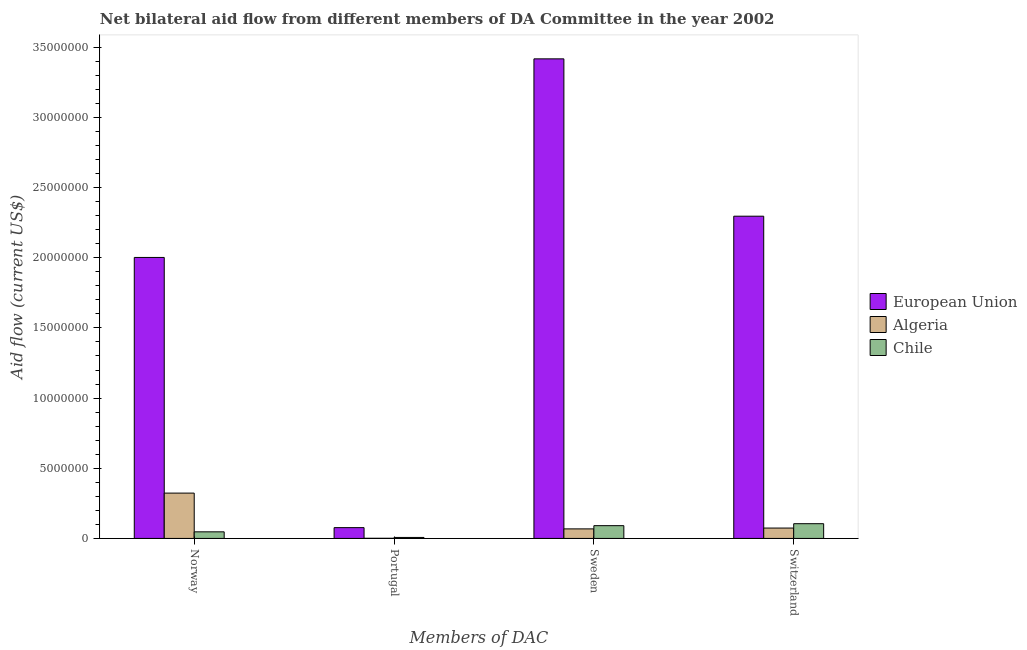How many bars are there on the 2nd tick from the left?
Provide a succinct answer. 3. How many bars are there on the 1st tick from the right?
Ensure brevity in your answer.  3. What is the amount of aid given by switzerland in Algeria?
Provide a succinct answer. 7.40e+05. Across all countries, what is the maximum amount of aid given by norway?
Keep it short and to the point. 2.00e+07. Across all countries, what is the minimum amount of aid given by sweden?
Your response must be concise. 6.80e+05. In which country was the amount of aid given by norway minimum?
Make the answer very short. Chile. What is the total amount of aid given by portugal in the graph?
Your answer should be very brief. 8.50e+05. What is the difference between the amount of aid given by switzerland in Chile and that in European Union?
Keep it short and to the point. -2.19e+07. What is the difference between the amount of aid given by portugal in European Union and the amount of aid given by norway in Algeria?
Ensure brevity in your answer.  -2.46e+06. What is the average amount of aid given by sweden per country?
Offer a terse response. 1.19e+07. What is the difference between the amount of aid given by switzerland and amount of aid given by sweden in Chile?
Make the answer very short. 1.40e+05. In how many countries, is the amount of aid given by norway greater than 29000000 US$?
Offer a terse response. 0. What is the ratio of the amount of aid given by sweden in European Union to that in Chile?
Provide a short and direct response. 37.55. Is the amount of aid given by sweden in European Union less than that in Chile?
Provide a succinct answer. No. Is the difference between the amount of aid given by sweden in European Union and Chile greater than the difference between the amount of aid given by portugal in European Union and Chile?
Ensure brevity in your answer.  Yes. What is the difference between the highest and the second highest amount of aid given by sweden?
Your answer should be very brief. 3.33e+07. What is the difference between the highest and the lowest amount of aid given by norway?
Make the answer very short. 1.96e+07. In how many countries, is the amount of aid given by portugal greater than the average amount of aid given by portugal taken over all countries?
Your answer should be very brief. 1. Is it the case that in every country, the sum of the amount of aid given by sweden and amount of aid given by switzerland is greater than the sum of amount of aid given by portugal and amount of aid given by norway?
Make the answer very short. Yes. What does the 1st bar from the right in Sweden represents?
Provide a succinct answer. Chile. What is the difference between two consecutive major ticks on the Y-axis?
Your response must be concise. 5.00e+06. Are the values on the major ticks of Y-axis written in scientific E-notation?
Your answer should be very brief. No. Does the graph contain any zero values?
Keep it short and to the point. No. Where does the legend appear in the graph?
Offer a terse response. Center right. How many legend labels are there?
Offer a terse response. 3. How are the legend labels stacked?
Your answer should be very brief. Vertical. What is the title of the graph?
Your answer should be very brief. Net bilateral aid flow from different members of DA Committee in the year 2002. Does "Australia" appear as one of the legend labels in the graph?
Keep it short and to the point. No. What is the label or title of the X-axis?
Keep it short and to the point. Members of DAC. What is the Aid flow (current US$) of European Union in Norway?
Provide a short and direct response. 2.00e+07. What is the Aid flow (current US$) of Algeria in Norway?
Offer a very short reply. 3.23e+06. What is the Aid flow (current US$) in European Union in Portugal?
Offer a terse response. 7.70e+05. What is the Aid flow (current US$) of Algeria in Portugal?
Provide a succinct answer. 10000. What is the Aid flow (current US$) in Chile in Portugal?
Ensure brevity in your answer.  7.00e+04. What is the Aid flow (current US$) of European Union in Sweden?
Your answer should be very brief. 3.42e+07. What is the Aid flow (current US$) of Algeria in Sweden?
Provide a short and direct response. 6.80e+05. What is the Aid flow (current US$) of Chile in Sweden?
Your answer should be very brief. 9.10e+05. What is the Aid flow (current US$) of European Union in Switzerland?
Your answer should be compact. 2.30e+07. What is the Aid flow (current US$) of Algeria in Switzerland?
Keep it short and to the point. 7.40e+05. What is the Aid flow (current US$) of Chile in Switzerland?
Keep it short and to the point. 1.05e+06. Across all Members of DAC, what is the maximum Aid flow (current US$) in European Union?
Give a very brief answer. 3.42e+07. Across all Members of DAC, what is the maximum Aid flow (current US$) in Algeria?
Ensure brevity in your answer.  3.23e+06. Across all Members of DAC, what is the maximum Aid flow (current US$) in Chile?
Your answer should be compact. 1.05e+06. Across all Members of DAC, what is the minimum Aid flow (current US$) of European Union?
Ensure brevity in your answer.  7.70e+05. Across all Members of DAC, what is the minimum Aid flow (current US$) in Algeria?
Provide a short and direct response. 10000. What is the total Aid flow (current US$) of European Union in the graph?
Offer a very short reply. 7.79e+07. What is the total Aid flow (current US$) of Algeria in the graph?
Offer a terse response. 4.66e+06. What is the total Aid flow (current US$) of Chile in the graph?
Keep it short and to the point. 2.50e+06. What is the difference between the Aid flow (current US$) of European Union in Norway and that in Portugal?
Your response must be concise. 1.92e+07. What is the difference between the Aid flow (current US$) in Algeria in Norway and that in Portugal?
Offer a very short reply. 3.22e+06. What is the difference between the Aid flow (current US$) of European Union in Norway and that in Sweden?
Your answer should be compact. -1.42e+07. What is the difference between the Aid flow (current US$) of Algeria in Norway and that in Sweden?
Offer a very short reply. 2.55e+06. What is the difference between the Aid flow (current US$) of Chile in Norway and that in Sweden?
Your answer should be very brief. -4.40e+05. What is the difference between the Aid flow (current US$) of European Union in Norway and that in Switzerland?
Your response must be concise. -2.94e+06. What is the difference between the Aid flow (current US$) in Algeria in Norway and that in Switzerland?
Your answer should be compact. 2.49e+06. What is the difference between the Aid flow (current US$) in Chile in Norway and that in Switzerland?
Keep it short and to the point. -5.80e+05. What is the difference between the Aid flow (current US$) in European Union in Portugal and that in Sweden?
Offer a very short reply. -3.34e+07. What is the difference between the Aid flow (current US$) in Algeria in Portugal and that in Sweden?
Ensure brevity in your answer.  -6.70e+05. What is the difference between the Aid flow (current US$) of Chile in Portugal and that in Sweden?
Give a very brief answer. -8.40e+05. What is the difference between the Aid flow (current US$) of European Union in Portugal and that in Switzerland?
Ensure brevity in your answer.  -2.22e+07. What is the difference between the Aid flow (current US$) in Algeria in Portugal and that in Switzerland?
Offer a terse response. -7.30e+05. What is the difference between the Aid flow (current US$) in Chile in Portugal and that in Switzerland?
Provide a succinct answer. -9.80e+05. What is the difference between the Aid flow (current US$) in European Union in Sweden and that in Switzerland?
Keep it short and to the point. 1.12e+07. What is the difference between the Aid flow (current US$) of Algeria in Sweden and that in Switzerland?
Offer a very short reply. -6.00e+04. What is the difference between the Aid flow (current US$) of European Union in Norway and the Aid flow (current US$) of Algeria in Portugal?
Give a very brief answer. 2.00e+07. What is the difference between the Aid flow (current US$) of European Union in Norway and the Aid flow (current US$) of Chile in Portugal?
Your answer should be very brief. 2.00e+07. What is the difference between the Aid flow (current US$) in Algeria in Norway and the Aid flow (current US$) in Chile in Portugal?
Provide a short and direct response. 3.16e+06. What is the difference between the Aid flow (current US$) in European Union in Norway and the Aid flow (current US$) in Algeria in Sweden?
Your answer should be very brief. 1.93e+07. What is the difference between the Aid flow (current US$) in European Union in Norway and the Aid flow (current US$) in Chile in Sweden?
Your answer should be very brief. 1.91e+07. What is the difference between the Aid flow (current US$) in Algeria in Norway and the Aid flow (current US$) in Chile in Sweden?
Give a very brief answer. 2.32e+06. What is the difference between the Aid flow (current US$) of European Union in Norway and the Aid flow (current US$) of Algeria in Switzerland?
Offer a terse response. 1.93e+07. What is the difference between the Aid flow (current US$) of European Union in Norway and the Aid flow (current US$) of Chile in Switzerland?
Provide a short and direct response. 1.90e+07. What is the difference between the Aid flow (current US$) of Algeria in Norway and the Aid flow (current US$) of Chile in Switzerland?
Make the answer very short. 2.18e+06. What is the difference between the Aid flow (current US$) of European Union in Portugal and the Aid flow (current US$) of Algeria in Sweden?
Provide a short and direct response. 9.00e+04. What is the difference between the Aid flow (current US$) of Algeria in Portugal and the Aid flow (current US$) of Chile in Sweden?
Make the answer very short. -9.00e+05. What is the difference between the Aid flow (current US$) in European Union in Portugal and the Aid flow (current US$) in Algeria in Switzerland?
Your response must be concise. 3.00e+04. What is the difference between the Aid flow (current US$) of European Union in Portugal and the Aid flow (current US$) of Chile in Switzerland?
Offer a very short reply. -2.80e+05. What is the difference between the Aid flow (current US$) of Algeria in Portugal and the Aid flow (current US$) of Chile in Switzerland?
Offer a terse response. -1.04e+06. What is the difference between the Aid flow (current US$) in European Union in Sweden and the Aid flow (current US$) in Algeria in Switzerland?
Give a very brief answer. 3.34e+07. What is the difference between the Aid flow (current US$) of European Union in Sweden and the Aid flow (current US$) of Chile in Switzerland?
Offer a very short reply. 3.31e+07. What is the difference between the Aid flow (current US$) of Algeria in Sweden and the Aid flow (current US$) of Chile in Switzerland?
Make the answer very short. -3.70e+05. What is the average Aid flow (current US$) of European Union per Members of DAC?
Make the answer very short. 1.95e+07. What is the average Aid flow (current US$) of Algeria per Members of DAC?
Ensure brevity in your answer.  1.16e+06. What is the average Aid flow (current US$) in Chile per Members of DAC?
Offer a terse response. 6.25e+05. What is the difference between the Aid flow (current US$) of European Union and Aid flow (current US$) of Algeria in Norway?
Offer a very short reply. 1.68e+07. What is the difference between the Aid flow (current US$) of European Union and Aid flow (current US$) of Chile in Norway?
Offer a very short reply. 1.96e+07. What is the difference between the Aid flow (current US$) in Algeria and Aid flow (current US$) in Chile in Norway?
Make the answer very short. 2.76e+06. What is the difference between the Aid flow (current US$) in European Union and Aid flow (current US$) in Algeria in Portugal?
Provide a short and direct response. 7.60e+05. What is the difference between the Aid flow (current US$) of European Union and Aid flow (current US$) of Algeria in Sweden?
Keep it short and to the point. 3.35e+07. What is the difference between the Aid flow (current US$) in European Union and Aid flow (current US$) in Chile in Sweden?
Ensure brevity in your answer.  3.33e+07. What is the difference between the Aid flow (current US$) of Algeria and Aid flow (current US$) of Chile in Sweden?
Your answer should be compact. -2.30e+05. What is the difference between the Aid flow (current US$) of European Union and Aid flow (current US$) of Algeria in Switzerland?
Offer a very short reply. 2.22e+07. What is the difference between the Aid flow (current US$) in European Union and Aid flow (current US$) in Chile in Switzerland?
Offer a very short reply. 2.19e+07. What is the difference between the Aid flow (current US$) of Algeria and Aid flow (current US$) of Chile in Switzerland?
Offer a terse response. -3.10e+05. What is the ratio of the Aid flow (current US$) of European Union in Norway to that in Portugal?
Your response must be concise. 26. What is the ratio of the Aid flow (current US$) in Algeria in Norway to that in Portugal?
Make the answer very short. 323. What is the ratio of the Aid flow (current US$) in Chile in Norway to that in Portugal?
Ensure brevity in your answer.  6.71. What is the ratio of the Aid flow (current US$) in European Union in Norway to that in Sweden?
Provide a succinct answer. 0.59. What is the ratio of the Aid flow (current US$) of Algeria in Norway to that in Sweden?
Your answer should be very brief. 4.75. What is the ratio of the Aid flow (current US$) of Chile in Norway to that in Sweden?
Keep it short and to the point. 0.52. What is the ratio of the Aid flow (current US$) in European Union in Norway to that in Switzerland?
Offer a terse response. 0.87. What is the ratio of the Aid flow (current US$) of Algeria in Norway to that in Switzerland?
Offer a very short reply. 4.36. What is the ratio of the Aid flow (current US$) of Chile in Norway to that in Switzerland?
Give a very brief answer. 0.45. What is the ratio of the Aid flow (current US$) of European Union in Portugal to that in Sweden?
Offer a very short reply. 0.02. What is the ratio of the Aid flow (current US$) of Algeria in Portugal to that in Sweden?
Keep it short and to the point. 0.01. What is the ratio of the Aid flow (current US$) of Chile in Portugal to that in Sweden?
Offer a terse response. 0.08. What is the ratio of the Aid flow (current US$) in European Union in Portugal to that in Switzerland?
Offer a very short reply. 0.03. What is the ratio of the Aid flow (current US$) of Algeria in Portugal to that in Switzerland?
Keep it short and to the point. 0.01. What is the ratio of the Aid flow (current US$) of Chile in Portugal to that in Switzerland?
Ensure brevity in your answer.  0.07. What is the ratio of the Aid flow (current US$) in European Union in Sweden to that in Switzerland?
Your answer should be very brief. 1.49. What is the ratio of the Aid flow (current US$) of Algeria in Sweden to that in Switzerland?
Keep it short and to the point. 0.92. What is the ratio of the Aid flow (current US$) of Chile in Sweden to that in Switzerland?
Offer a terse response. 0.87. What is the difference between the highest and the second highest Aid flow (current US$) of European Union?
Provide a short and direct response. 1.12e+07. What is the difference between the highest and the second highest Aid flow (current US$) in Algeria?
Keep it short and to the point. 2.49e+06. What is the difference between the highest and the second highest Aid flow (current US$) in Chile?
Offer a very short reply. 1.40e+05. What is the difference between the highest and the lowest Aid flow (current US$) in European Union?
Keep it short and to the point. 3.34e+07. What is the difference between the highest and the lowest Aid flow (current US$) in Algeria?
Provide a short and direct response. 3.22e+06. What is the difference between the highest and the lowest Aid flow (current US$) in Chile?
Provide a succinct answer. 9.80e+05. 